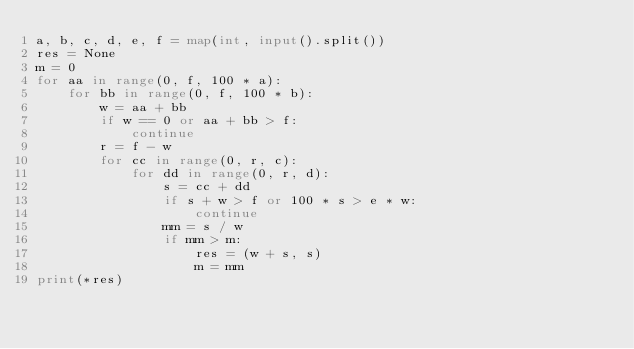<code> <loc_0><loc_0><loc_500><loc_500><_Python_>a, b, c, d, e, f = map(int, input().split())
res = None
m = 0
for aa in range(0, f, 100 * a):
    for bb in range(0, f, 100 * b):
        w = aa + bb
        if w == 0 or aa + bb > f:
            continue
        r = f - w
        for cc in range(0, r, c):
            for dd in range(0, r, d):
                s = cc + dd
                if s + w > f or 100 * s > e * w:
                    continue
                mm = s / w
                if mm > m:
                    res = (w + s, s)
                    m = mm
print(*res)</code> 